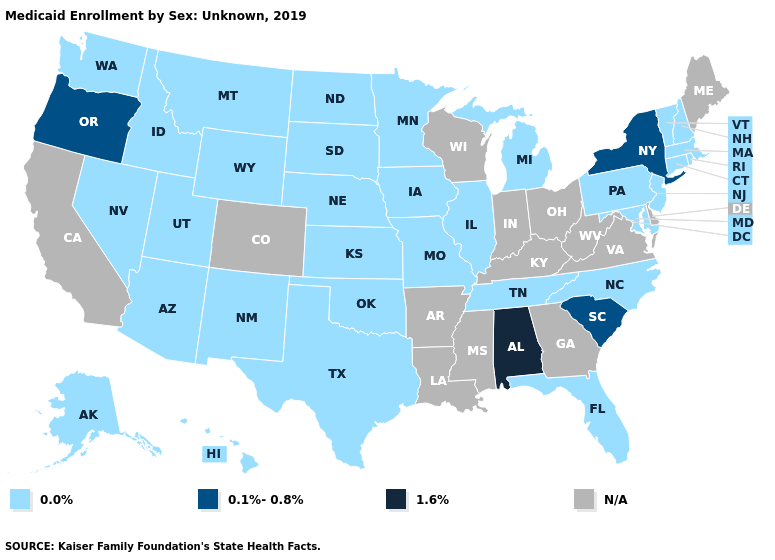Does the first symbol in the legend represent the smallest category?
Keep it brief. Yes. What is the lowest value in the West?
Short answer required. 0.0%. Among the states that border Idaho , does Montana have the lowest value?
Concise answer only. Yes. What is the value of Delaware?
Quick response, please. N/A. What is the value of Wyoming?
Concise answer only. 0.0%. Name the states that have a value in the range 0.0%?
Quick response, please. Alaska, Arizona, Connecticut, Florida, Hawaii, Idaho, Illinois, Iowa, Kansas, Maryland, Massachusetts, Michigan, Minnesota, Missouri, Montana, Nebraska, Nevada, New Hampshire, New Jersey, New Mexico, North Carolina, North Dakota, Oklahoma, Pennsylvania, Rhode Island, South Dakota, Tennessee, Texas, Utah, Vermont, Washington, Wyoming. Among the states that border Nebraska , which have the highest value?
Write a very short answer. Iowa, Kansas, Missouri, South Dakota, Wyoming. Name the states that have a value in the range 0.1%-0.8%?
Concise answer only. New York, Oregon, South Carolina. What is the value of Louisiana?
Keep it brief. N/A. Name the states that have a value in the range 0.0%?
Be succinct. Alaska, Arizona, Connecticut, Florida, Hawaii, Idaho, Illinois, Iowa, Kansas, Maryland, Massachusetts, Michigan, Minnesota, Missouri, Montana, Nebraska, Nevada, New Hampshire, New Jersey, New Mexico, North Carolina, North Dakota, Oklahoma, Pennsylvania, Rhode Island, South Dakota, Tennessee, Texas, Utah, Vermont, Washington, Wyoming. Name the states that have a value in the range 0.1%-0.8%?
Write a very short answer. New York, Oregon, South Carolina. What is the lowest value in the USA?
Keep it brief. 0.0%. What is the highest value in the West ?
Be succinct. 0.1%-0.8%. What is the value of Massachusetts?
Quick response, please. 0.0%. 